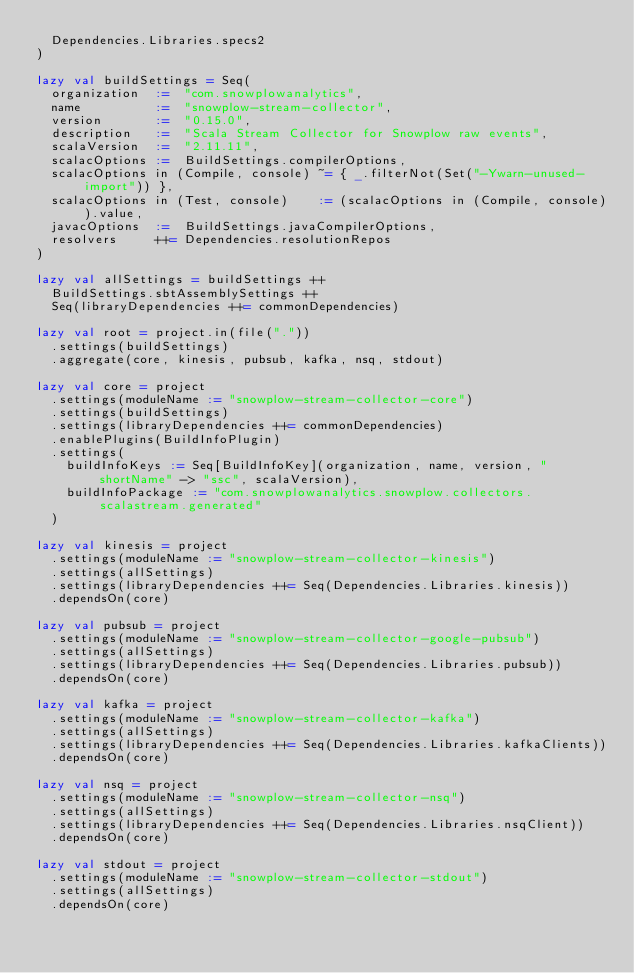Convert code to text. <code><loc_0><loc_0><loc_500><loc_500><_Scala_>  Dependencies.Libraries.specs2
)

lazy val buildSettings = Seq(
  organization  :=  "com.snowplowanalytics",
  name          :=  "snowplow-stream-collector",
  version       :=  "0.15.0",
  description   :=  "Scala Stream Collector for Snowplow raw events",
  scalaVersion  :=  "2.11.11",
  scalacOptions :=  BuildSettings.compilerOptions,
  scalacOptions in (Compile, console) ~= { _.filterNot(Set("-Ywarn-unused-import")) },
  scalacOptions in (Test, console)    := (scalacOptions in (Compile, console)).value,
  javacOptions  :=  BuildSettings.javaCompilerOptions,
  resolvers     ++= Dependencies.resolutionRepos
)

lazy val allSettings = buildSettings ++
  BuildSettings.sbtAssemblySettings ++
  Seq(libraryDependencies ++= commonDependencies)

lazy val root = project.in(file("."))
  .settings(buildSettings)
  .aggregate(core, kinesis, pubsub, kafka, nsq, stdout)

lazy val core = project
  .settings(moduleName := "snowplow-stream-collector-core")
  .settings(buildSettings)
  .settings(libraryDependencies ++= commonDependencies)
  .enablePlugins(BuildInfoPlugin)
  .settings(
    buildInfoKeys := Seq[BuildInfoKey](organization, name, version, "shortName" -> "ssc", scalaVersion),
    buildInfoPackage := "com.snowplowanalytics.snowplow.collectors.scalastream.generated"
  )

lazy val kinesis = project
  .settings(moduleName := "snowplow-stream-collector-kinesis")
  .settings(allSettings)
  .settings(libraryDependencies ++= Seq(Dependencies.Libraries.kinesis))
  .dependsOn(core)

lazy val pubsub = project
  .settings(moduleName := "snowplow-stream-collector-google-pubsub")
  .settings(allSettings)
  .settings(libraryDependencies ++= Seq(Dependencies.Libraries.pubsub))
  .dependsOn(core)

lazy val kafka = project
  .settings(moduleName := "snowplow-stream-collector-kafka")
  .settings(allSettings)
  .settings(libraryDependencies ++= Seq(Dependencies.Libraries.kafkaClients))
  .dependsOn(core)

lazy val nsq = project
  .settings(moduleName := "snowplow-stream-collector-nsq")
  .settings(allSettings)
  .settings(libraryDependencies ++= Seq(Dependencies.Libraries.nsqClient))
  .dependsOn(core)

lazy val stdout = project
  .settings(moduleName := "snowplow-stream-collector-stdout")
  .settings(allSettings)
  .dependsOn(core)
</code> 